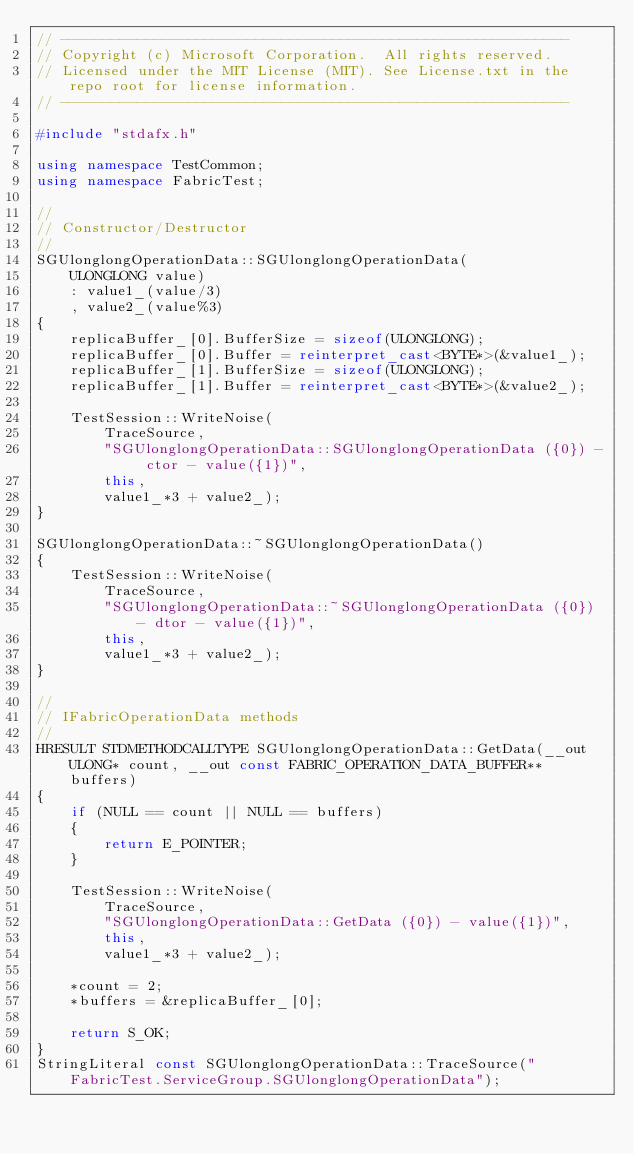Convert code to text. <code><loc_0><loc_0><loc_500><loc_500><_C++_>// ------------------------------------------------------------
// Copyright (c) Microsoft Corporation.  All rights reserved.
// Licensed under the MIT License (MIT). See License.txt in the repo root for license information.
// ------------------------------------------------------------

#include "stdafx.h"

using namespace TestCommon;
using namespace FabricTest;

//
// Constructor/Destructor
//
SGUlonglongOperationData::SGUlonglongOperationData(
    ULONGLONG value)
    : value1_(value/3)
    , value2_(value%3)
{
    replicaBuffer_[0].BufferSize = sizeof(ULONGLONG);
    replicaBuffer_[0].Buffer = reinterpret_cast<BYTE*>(&value1_);
    replicaBuffer_[1].BufferSize = sizeof(ULONGLONG);
    replicaBuffer_[1].Buffer = reinterpret_cast<BYTE*>(&value2_);

    TestSession::WriteNoise(
        TraceSource, 
        "SGUlonglongOperationData::SGUlonglongOperationData ({0}) - ctor - value({1})",
        this,
        value1_*3 + value2_);
}

SGUlonglongOperationData::~SGUlonglongOperationData()
{
    TestSession::WriteNoise(
        TraceSource, 
        "SGUlonglongOperationData::~SGUlonglongOperationData ({0}) - dtor - value({1})",
        this,
        value1_*3 + value2_);
}

//
// IFabricOperationData methods
//
HRESULT STDMETHODCALLTYPE SGUlonglongOperationData::GetData(__out ULONG* count, __out const FABRIC_OPERATION_DATA_BUFFER** buffers)
{
    if (NULL == count || NULL == buffers)
    {
        return E_POINTER;
    }

    TestSession::WriteNoise(
        TraceSource, 
        "SGUlonglongOperationData::GetData ({0}) - value({1})",
        this,
        value1_*3 + value2_);

    *count = 2;
    *buffers = &replicaBuffer_[0];

    return S_OK;
}
StringLiteral const SGUlonglongOperationData::TraceSource("FabricTest.ServiceGroup.SGUlonglongOperationData");
</code> 